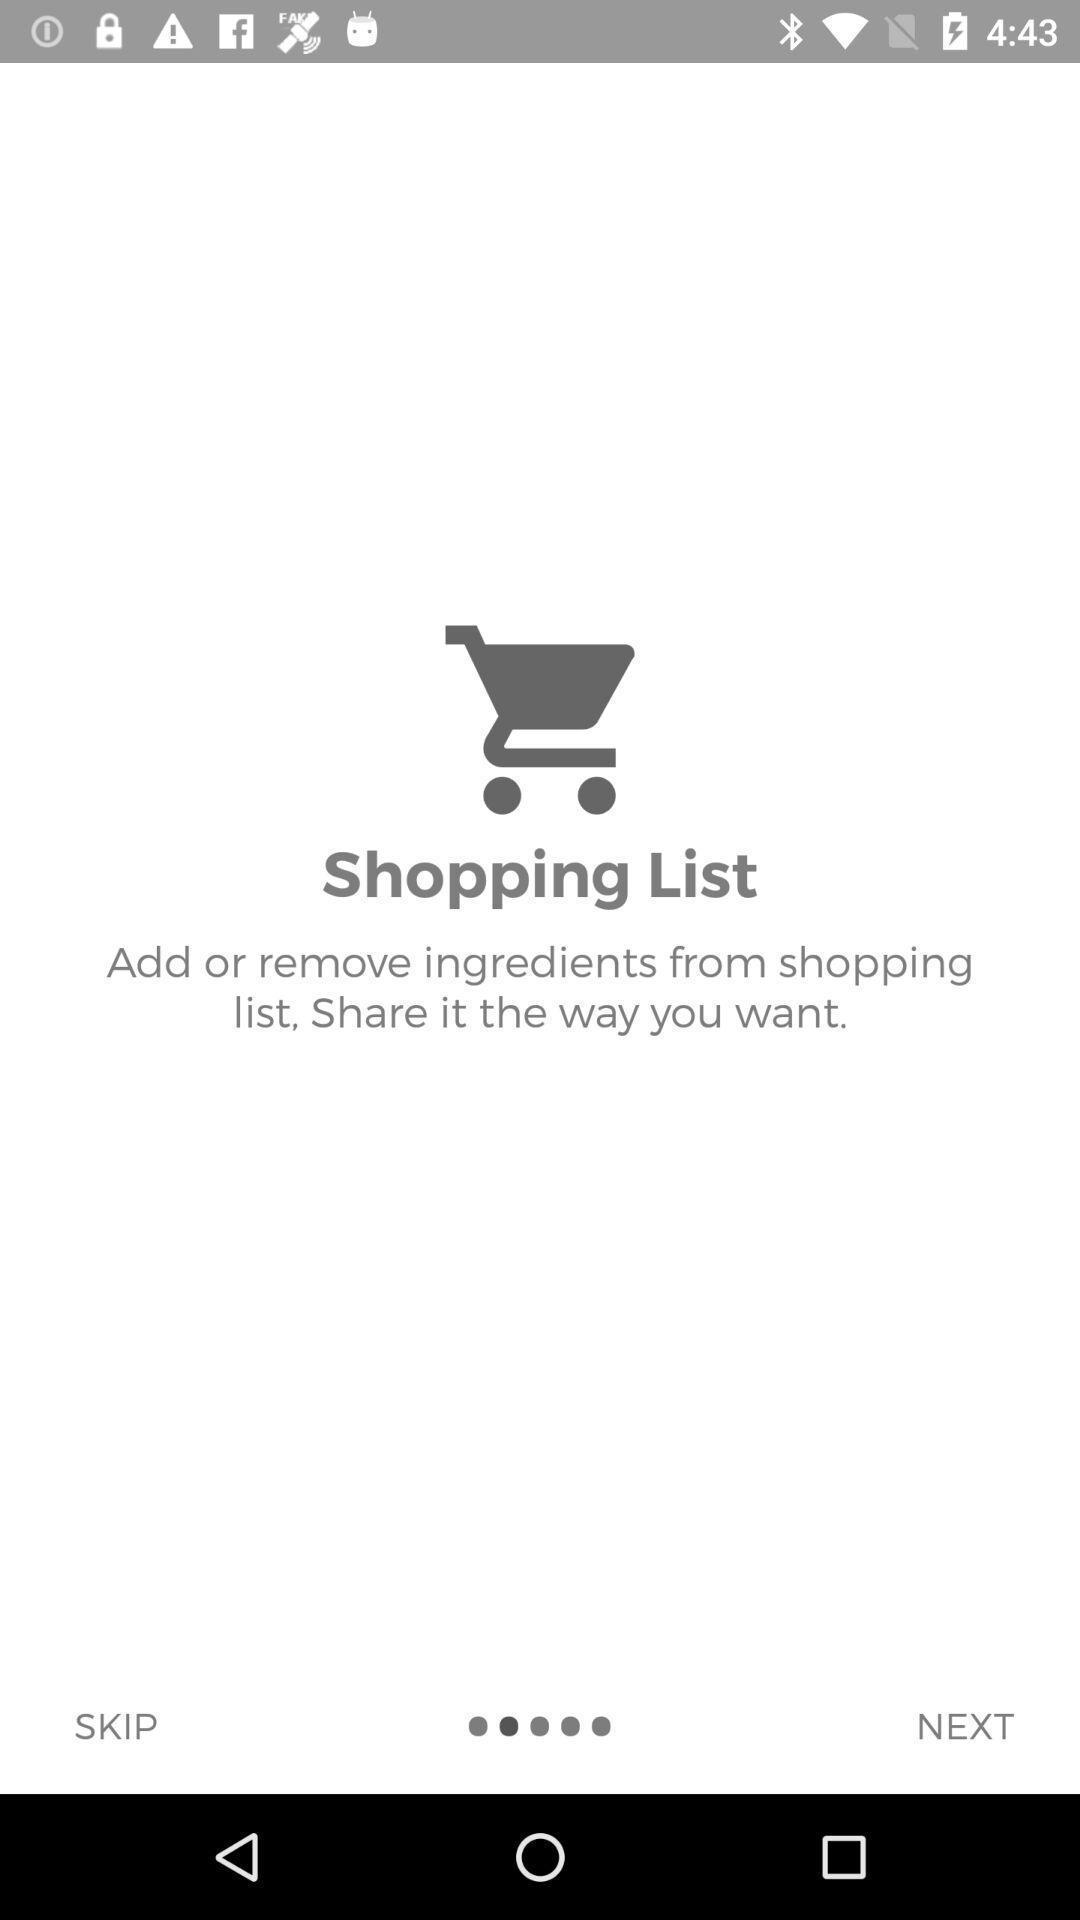Explain the elements present in this screenshot. Page that displaying shopping application. 